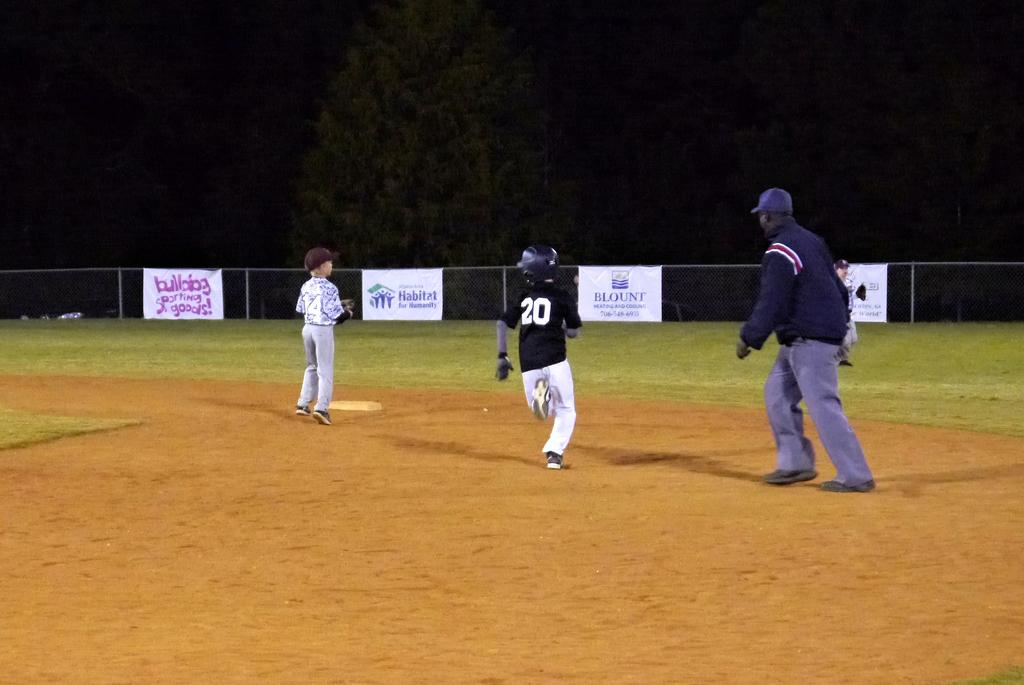<image>
Summarize the visual content of the image. Baseball player wearing number 20 running on the base. 